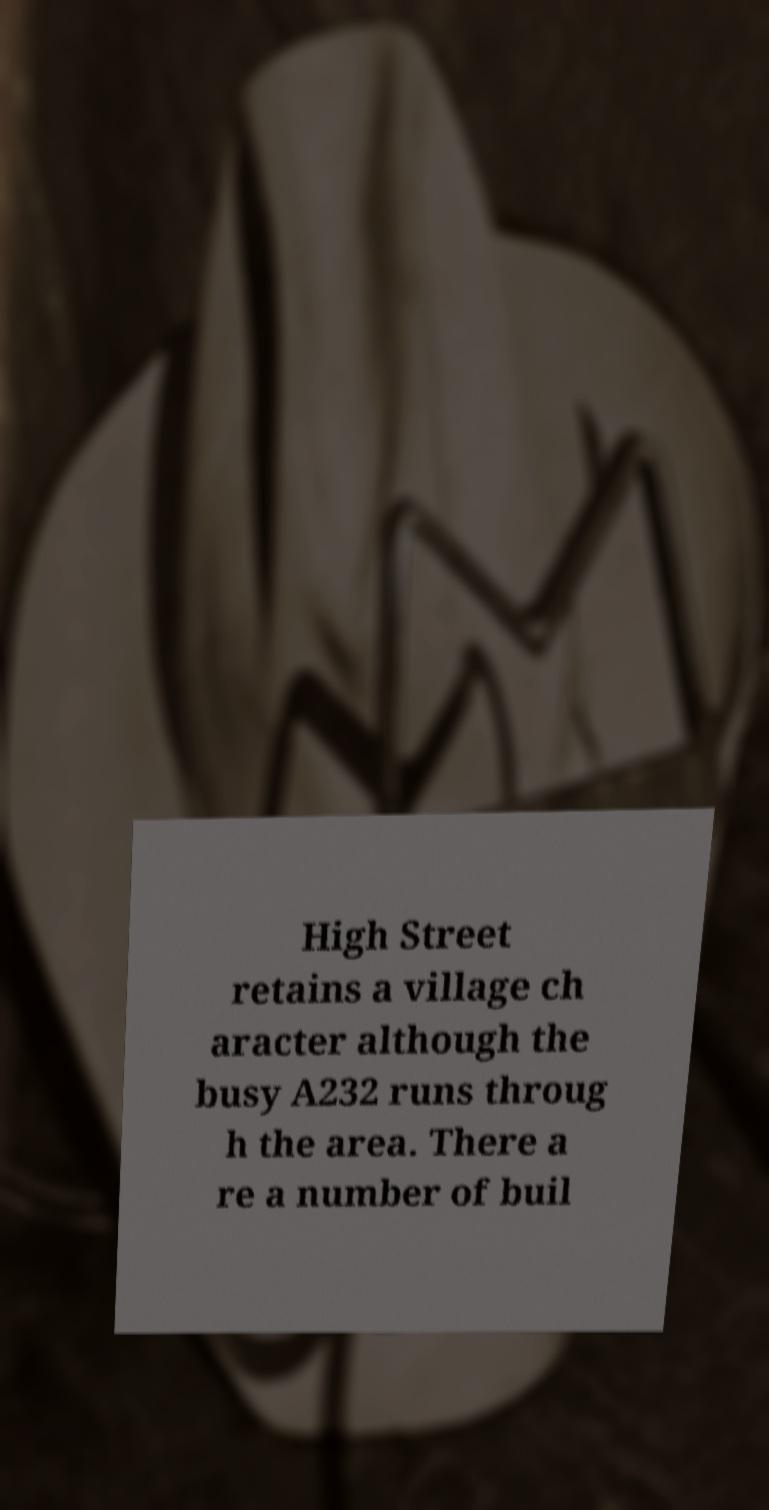Can you accurately transcribe the text from the provided image for me? High Street retains a village ch aracter although the busy A232 runs throug h the area. There a re a number of buil 